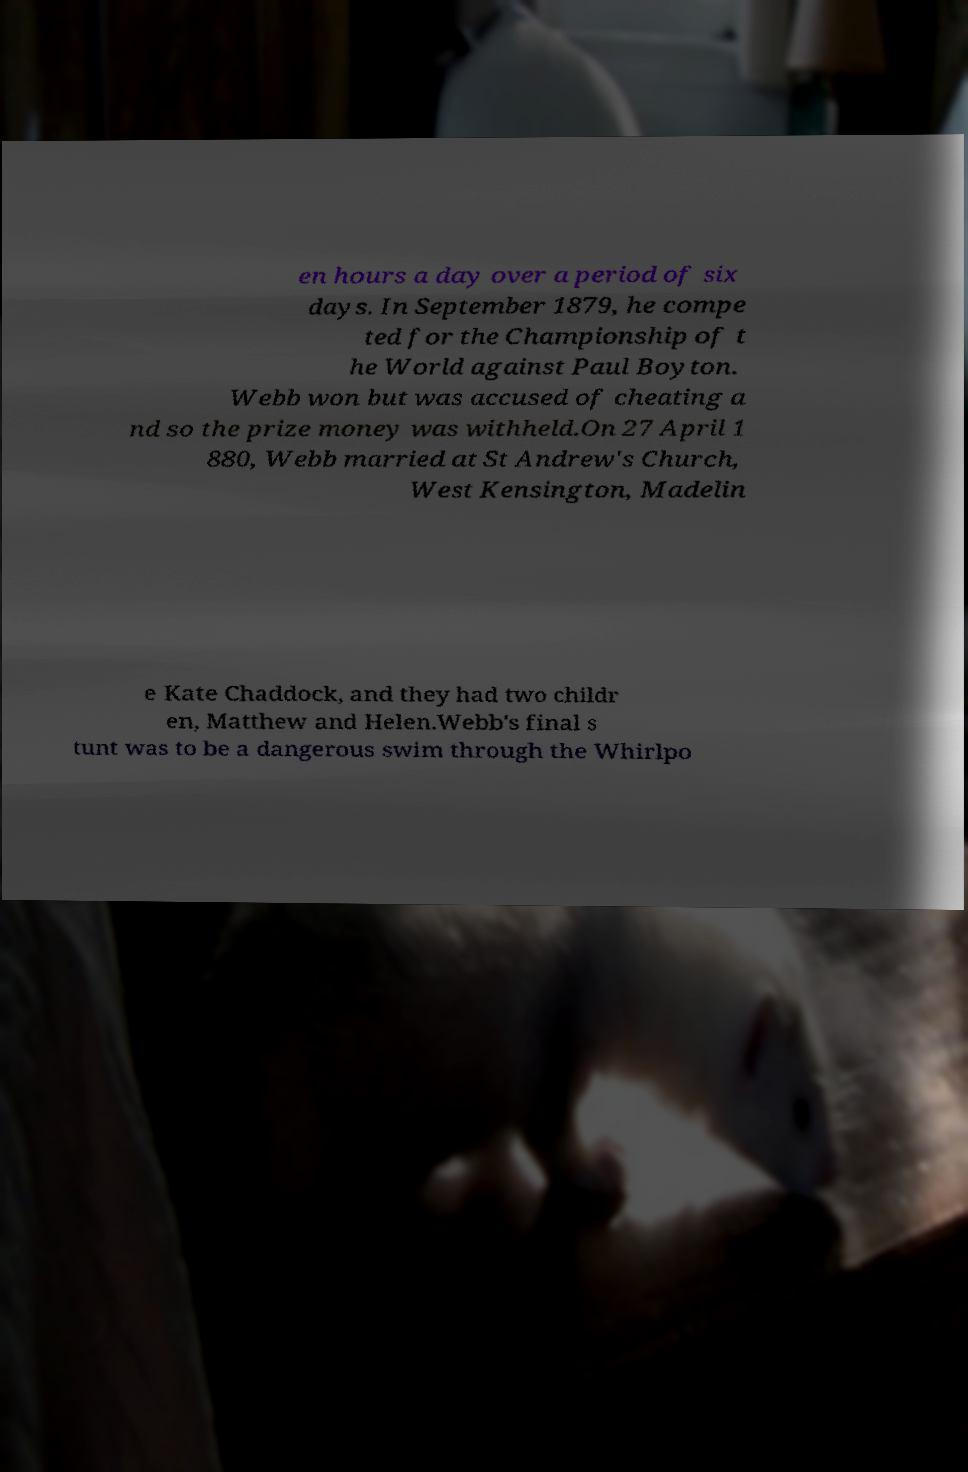I need the written content from this picture converted into text. Can you do that? en hours a day over a period of six days. In September 1879, he compe ted for the Championship of t he World against Paul Boyton. Webb won but was accused of cheating a nd so the prize money was withheld.On 27 April 1 880, Webb married at St Andrew's Church, West Kensington, Madelin e Kate Chaddock, and they had two childr en, Matthew and Helen.Webb's final s tunt was to be a dangerous swim through the Whirlpo 